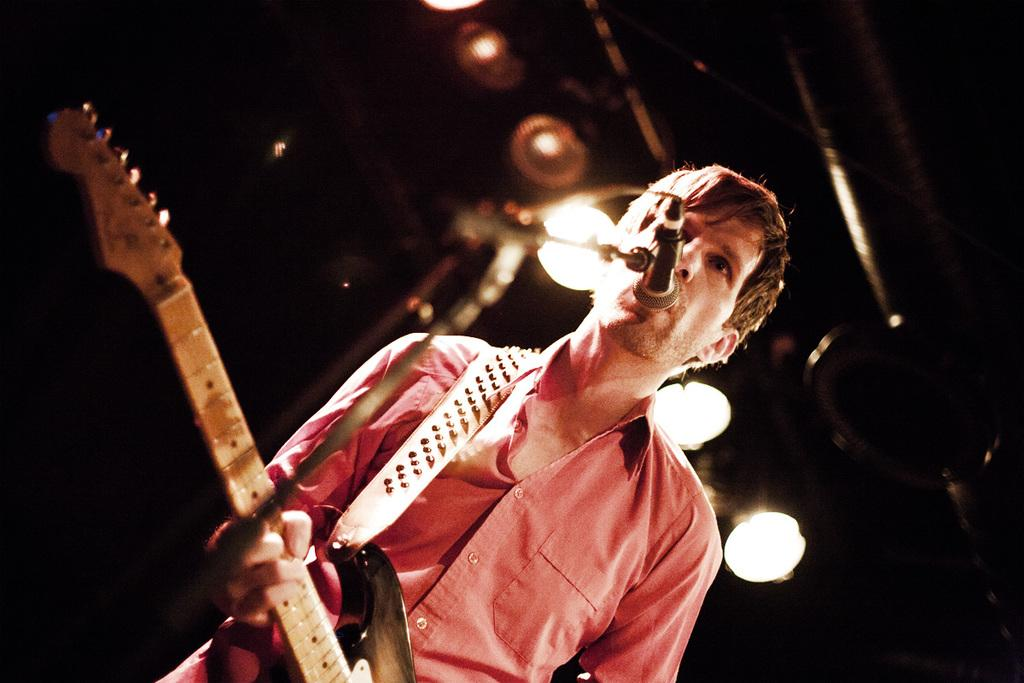Who is the main subject in the image? There is a boy in the image. What is the boy holding in the image? The boy is holding a guitar. What is the boy standing in front of in the image? The boy is standing in front of a microphone. What type of lighting is visible in the image? There are spotlights visible in the image. How many rings does the bear have on its paw in the image? There is no bear present in the image, and therefore no rings on its paw can be observed. 